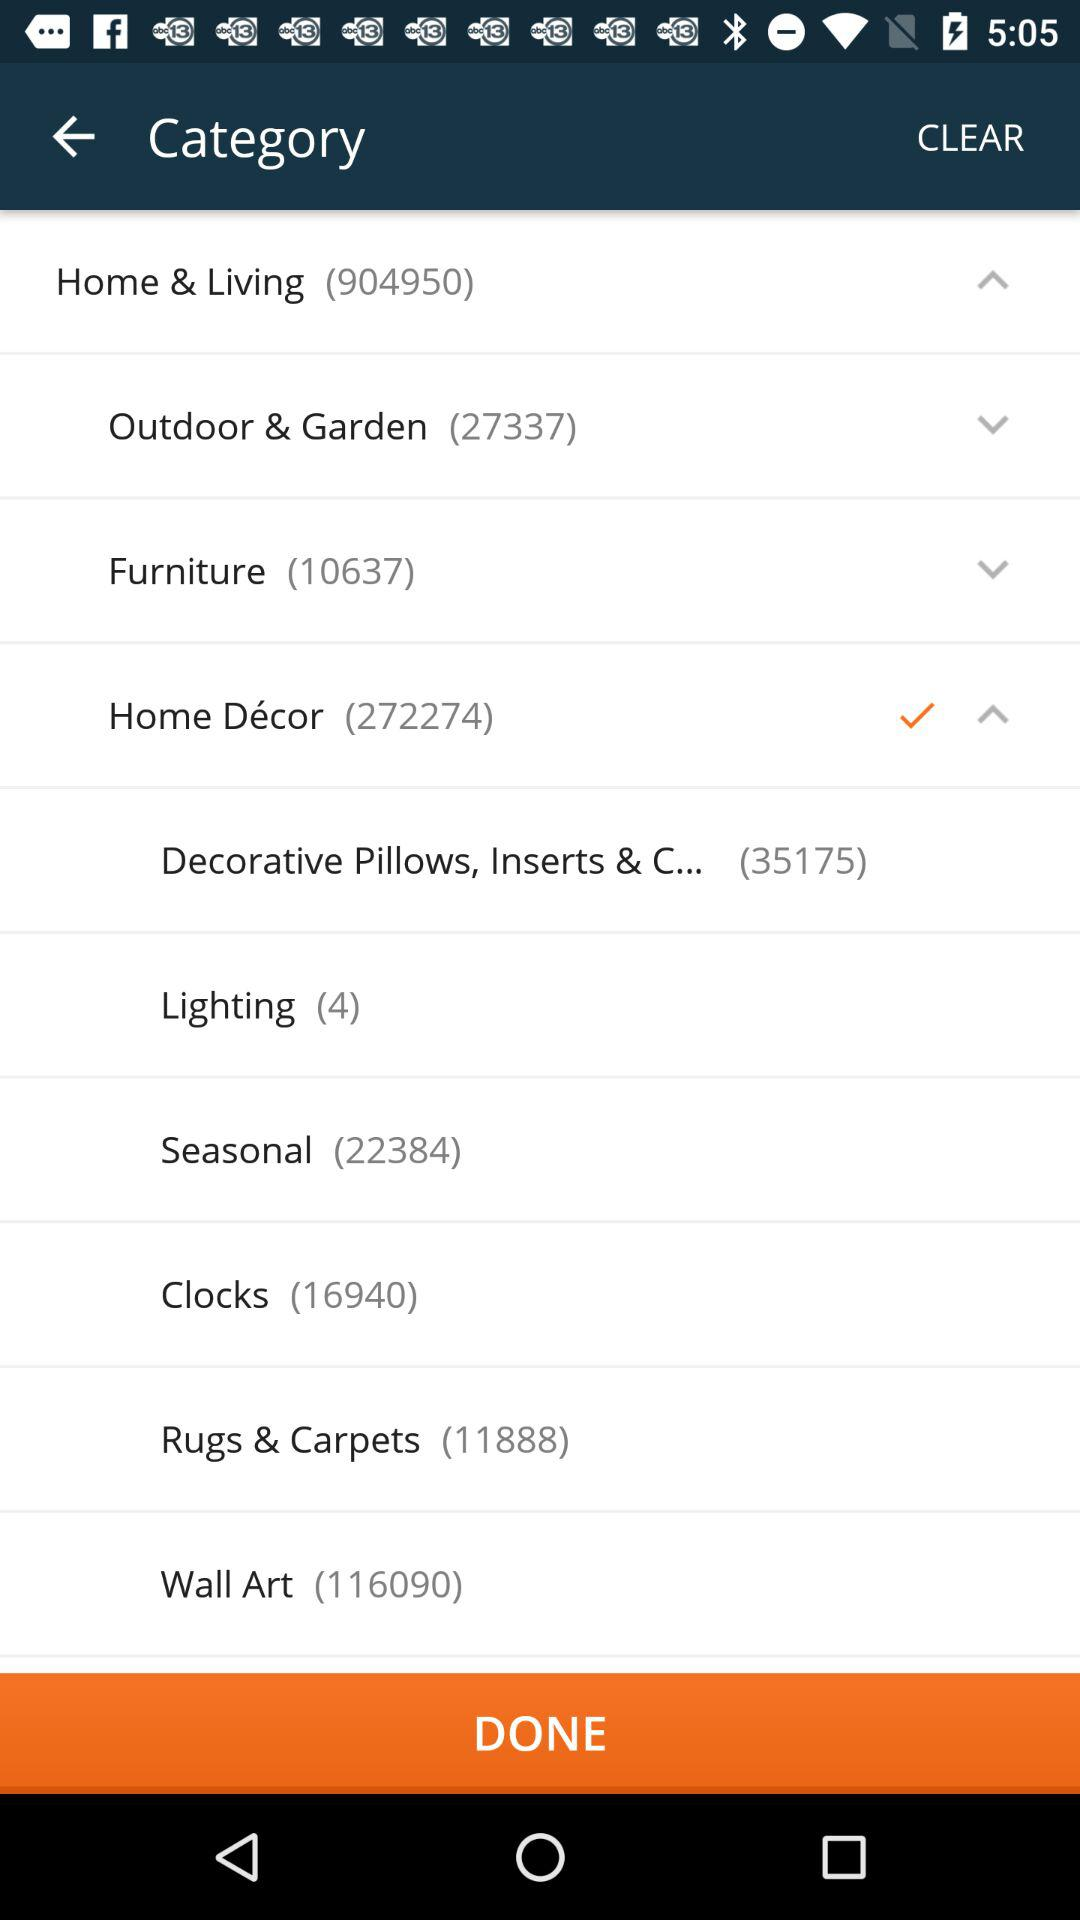What is the number of results for clocks? The number of results is 16,940. 